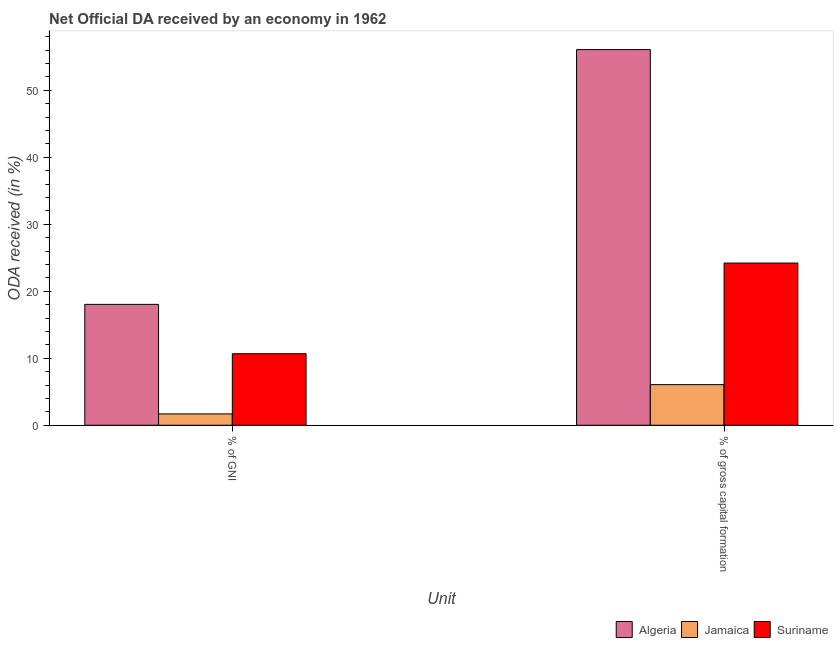Are the number of bars on each tick of the X-axis equal?
Your answer should be compact. Yes. How many bars are there on the 2nd tick from the left?
Provide a short and direct response. 3. How many bars are there on the 2nd tick from the right?
Make the answer very short. 3. What is the label of the 1st group of bars from the left?
Provide a succinct answer. % of GNI. What is the oda received as percentage of gross capital formation in Suriname?
Your answer should be compact. 24.22. Across all countries, what is the maximum oda received as percentage of gross capital formation?
Keep it short and to the point. 56.09. Across all countries, what is the minimum oda received as percentage of gni?
Your answer should be very brief. 1.69. In which country was the oda received as percentage of gross capital formation maximum?
Keep it short and to the point. Algeria. In which country was the oda received as percentage of gni minimum?
Give a very brief answer. Jamaica. What is the total oda received as percentage of gni in the graph?
Provide a succinct answer. 30.42. What is the difference between the oda received as percentage of gni in Algeria and that in Jamaica?
Provide a short and direct response. 16.36. What is the difference between the oda received as percentage of gross capital formation in Suriname and the oda received as percentage of gni in Algeria?
Give a very brief answer. 6.17. What is the average oda received as percentage of gross capital formation per country?
Offer a terse response. 28.79. What is the difference between the oda received as percentage of gni and oda received as percentage of gross capital formation in Suriname?
Your response must be concise. -13.54. In how many countries, is the oda received as percentage of gni greater than 54 %?
Keep it short and to the point. 0. What is the ratio of the oda received as percentage of gross capital formation in Algeria to that in Jamaica?
Give a very brief answer. 9.25. Is the oda received as percentage of gni in Jamaica less than that in Algeria?
Your answer should be very brief. Yes. What does the 1st bar from the left in % of gross capital formation represents?
Provide a succinct answer. Algeria. What does the 3rd bar from the right in % of GNI represents?
Your answer should be compact. Algeria. How many bars are there?
Your answer should be very brief. 6. Are all the bars in the graph horizontal?
Your answer should be very brief. No. What is the difference between two consecutive major ticks on the Y-axis?
Your answer should be compact. 10. What is the title of the graph?
Provide a succinct answer. Net Official DA received by an economy in 1962. Does "Turks and Caicos Islands" appear as one of the legend labels in the graph?
Provide a succinct answer. No. What is the label or title of the X-axis?
Offer a very short reply. Unit. What is the label or title of the Y-axis?
Provide a short and direct response. ODA received (in %). What is the ODA received (in %) of Algeria in % of GNI?
Offer a very short reply. 18.05. What is the ODA received (in %) of Jamaica in % of GNI?
Keep it short and to the point. 1.69. What is the ODA received (in %) in Suriname in % of GNI?
Keep it short and to the point. 10.68. What is the ODA received (in %) in Algeria in % of gross capital formation?
Your answer should be compact. 56.09. What is the ODA received (in %) in Jamaica in % of gross capital formation?
Make the answer very short. 6.06. What is the ODA received (in %) in Suriname in % of gross capital formation?
Keep it short and to the point. 24.22. Across all Unit, what is the maximum ODA received (in %) of Algeria?
Your response must be concise. 56.09. Across all Unit, what is the maximum ODA received (in %) of Jamaica?
Offer a very short reply. 6.06. Across all Unit, what is the maximum ODA received (in %) in Suriname?
Offer a very short reply. 24.22. Across all Unit, what is the minimum ODA received (in %) of Algeria?
Give a very brief answer. 18.05. Across all Unit, what is the minimum ODA received (in %) of Jamaica?
Offer a terse response. 1.69. Across all Unit, what is the minimum ODA received (in %) of Suriname?
Keep it short and to the point. 10.68. What is the total ODA received (in %) in Algeria in the graph?
Keep it short and to the point. 74.14. What is the total ODA received (in %) of Jamaica in the graph?
Your answer should be very brief. 7.76. What is the total ODA received (in %) of Suriname in the graph?
Offer a very short reply. 34.9. What is the difference between the ODA received (in %) in Algeria in % of GNI and that in % of gross capital formation?
Your answer should be very brief. -38.04. What is the difference between the ODA received (in %) of Jamaica in % of GNI and that in % of gross capital formation?
Provide a short and direct response. -4.37. What is the difference between the ODA received (in %) in Suriname in % of GNI and that in % of gross capital formation?
Your response must be concise. -13.54. What is the difference between the ODA received (in %) in Algeria in % of GNI and the ODA received (in %) in Jamaica in % of gross capital formation?
Provide a succinct answer. 11.98. What is the difference between the ODA received (in %) of Algeria in % of GNI and the ODA received (in %) of Suriname in % of gross capital formation?
Offer a terse response. -6.17. What is the difference between the ODA received (in %) of Jamaica in % of GNI and the ODA received (in %) of Suriname in % of gross capital formation?
Keep it short and to the point. -22.52. What is the average ODA received (in %) of Algeria per Unit?
Your answer should be compact. 37.07. What is the average ODA received (in %) in Jamaica per Unit?
Your answer should be compact. 3.88. What is the average ODA received (in %) in Suriname per Unit?
Your response must be concise. 17.45. What is the difference between the ODA received (in %) of Algeria and ODA received (in %) of Jamaica in % of GNI?
Make the answer very short. 16.36. What is the difference between the ODA received (in %) of Algeria and ODA received (in %) of Suriname in % of GNI?
Make the answer very short. 7.37. What is the difference between the ODA received (in %) of Jamaica and ODA received (in %) of Suriname in % of GNI?
Provide a succinct answer. -8.99. What is the difference between the ODA received (in %) of Algeria and ODA received (in %) of Jamaica in % of gross capital formation?
Offer a very short reply. 50.02. What is the difference between the ODA received (in %) of Algeria and ODA received (in %) of Suriname in % of gross capital formation?
Provide a short and direct response. 31.87. What is the difference between the ODA received (in %) of Jamaica and ODA received (in %) of Suriname in % of gross capital formation?
Provide a short and direct response. -18.15. What is the ratio of the ODA received (in %) of Algeria in % of GNI to that in % of gross capital formation?
Provide a short and direct response. 0.32. What is the ratio of the ODA received (in %) of Jamaica in % of GNI to that in % of gross capital formation?
Provide a short and direct response. 0.28. What is the ratio of the ODA received (in %) in Suriname in % of GNI to that in % of gross capital formation?
Offer a terse response. 0.44. What is the difference between the highest and the second highest ODA received (in %) of Algeria?
Your answer should be very brief. 38.04. What is the difference between the highest and the second highest ODA received (in %) in Jamaica?
Give a very brief answer. 4.37. What is the difference between the highest and the second highest ODA received (in %) of Suriname?
Your answer should be very brief. 13.54. What is the difference between the highest and the lowest ODA received (in %) in Algeria?
Keep it short and to the point. 38.04. What is the difference between the highest and the lowest ODA received (in %) in Jamaica?
Give a very brief answer. 4.37. What is the difference between the highest and the lowest ODA received (in %) of Suriname?
Ensure brevity in your answer.  13.54. 